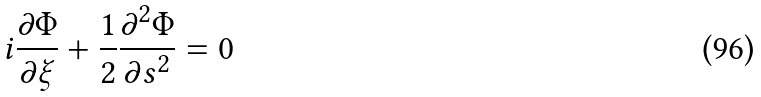Convert formula to latex. <formula><loc_0><loc_0><loc_500><loc_500>i \frac { \partial \Phi } { \partial \xi } + \frac { 1 } { 2 } \frac { \partial ^ { 2 } \Phi } { \partial s ^ { 2 } } = 0</formula> 